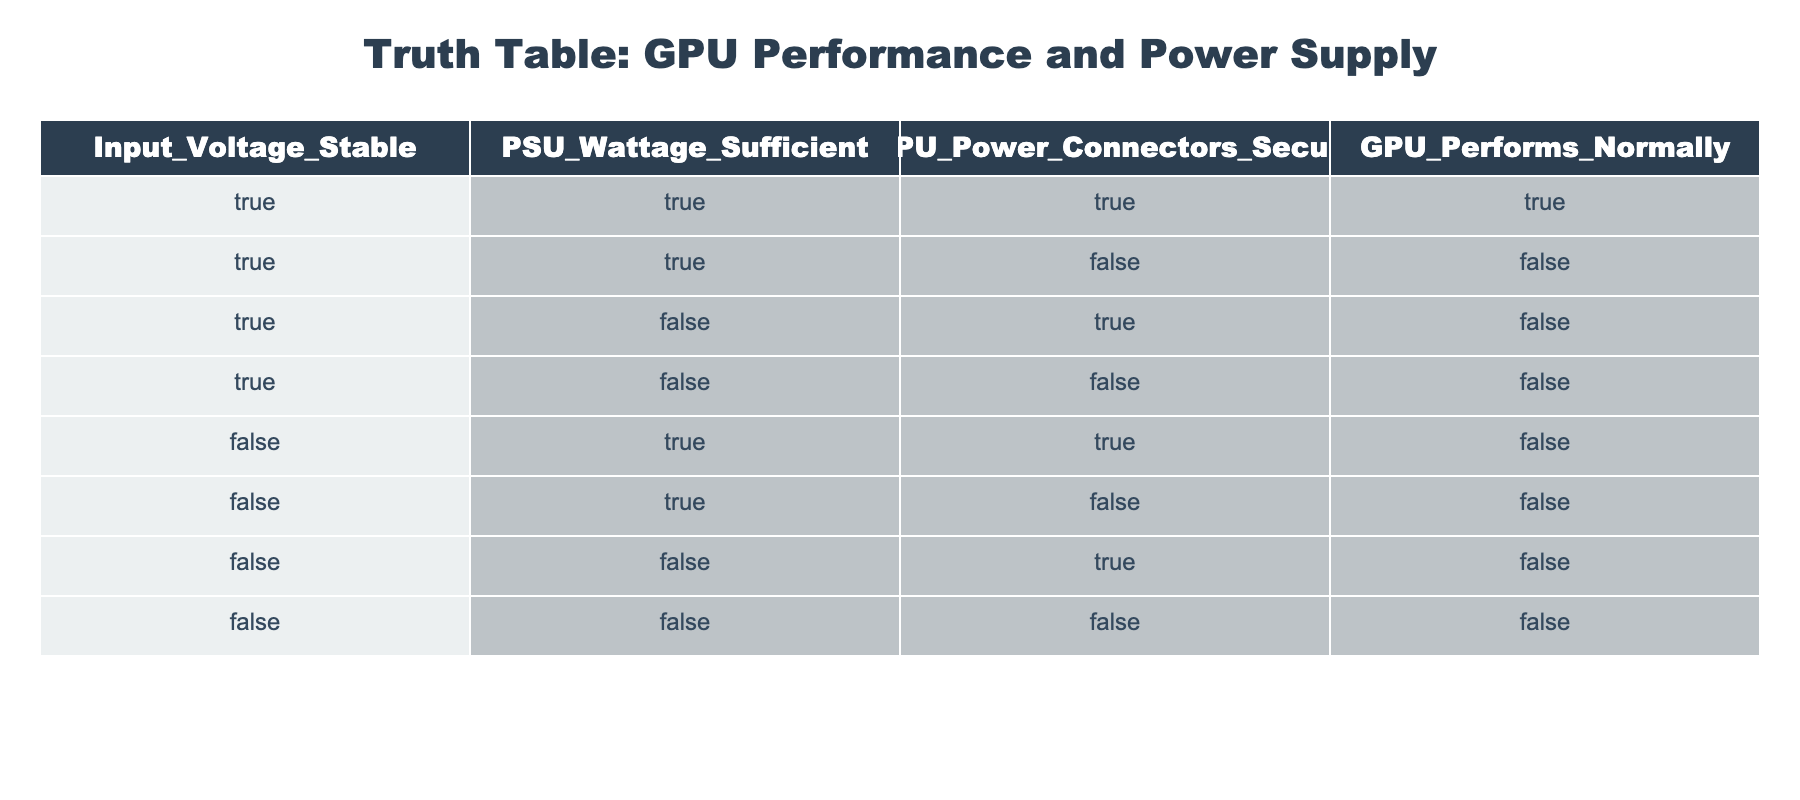What is the condition that results in the GPU performing normally? According to the table, the GPU performs normally only when Input Voltage is Stable, PSU Wattage is Sufficient, and GPU Power Connectors are Secure. This corresponds to the first row in the table.
Answer: True How many conditions lead to abnormal GPU performance? To find the conditions leading to abnormal GPU performance, we count the rows where GPU Performs Normally is False. There are 7 such rows in the table.
Answer: 7 Is the GPU performing normally if the Input Voltage is not Stable but the PSU Wattage is Sufficient? When the Input Voltage is not Stable (False) and PSU Wattage is Sufficient (True), as shown in the fifth and sixth rows, the GPU does not perform normally, indicated by False.
Answer: No What is the average wattage condition when the GPU fails to perform normally? From the table, we have 7 instances of abnormal performance. Next, we note the PSU Wattage conditions for these rows: (True, False, False, True, False, False). Out of these, 5 instances show insufficient wattage. Therefore, here, the average can be considered as more often insufficient with the presence of both conditions.
Answer: Insufficient Is it possible for the GPU to perform normally if one of the conditions is false? By analyzing the first row from the table, it reflects that for the GPU to perform normally, all three conditions must be true. If any of them is false, based on other rows, it cannot perform normally. Therefore, this creates a critical insight into how power supply is central to GPU performance.
Answer: No Under what specific conditions will the GPU perform abnormally when the Input Voltage is Stable? The table shows three instances where Input Voltage is Stable (True) and the GPU performs abnormally: the second, third, and fourth rows. In each of these cases, either the PSU Wattage is insufficient or the GPU power connectors are not secure, which leads to abnormal performance when Input Voltage is Stable.
Answer: PSU Wattage Insufficient or GPU Connectors Unsecure How many rows indicate sufficient PSU wattage but still abnormal GPU performance? Examining the table, the rows corresponding to sufficient PSU wattage (True) are the first, fifth, and sixth. Out of these, two of them (the fifth and sixth rows) show that the GPU does not perform normally.
Answer: 2 What can be concluded if the GPU does not perform normally and the Input Voltage is Stable? Looking at the possible combinations, if the GPU is not functioning normally and Input Voltage is Stable, we see from the second, third, and fourth rows that either the PSU Wattage is insufficient or GPU power connectors are not secure. This means stability in input voltage alone is not adequate for normal performance.
Answer: PSU Wattage Insufficient or Connectors Unsecure When will the GPU perform normally despite having voltage stability issues? The logic indicates that if the Input Voltage is not Stable (False), the GPU cannot perform normally, as shown in all cases when this condition is not met. Hence, it is impossible for normal GPU functioning under voltage stability issues.
Answer: Never 